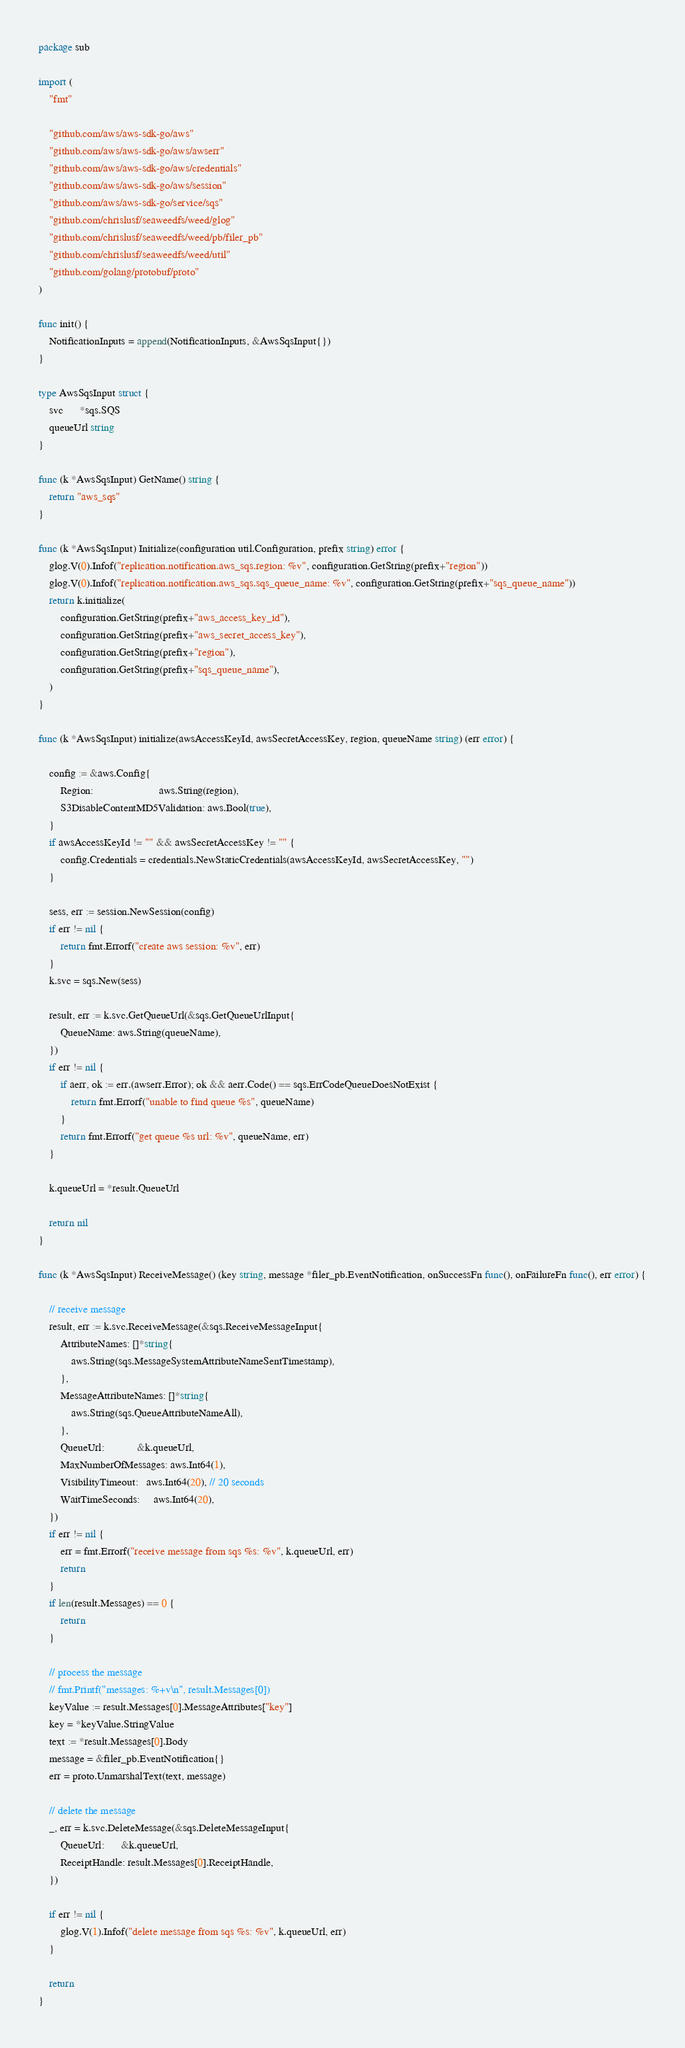<code> <loc_0><loc_0><loc_500><loc_500><_Go_>package sub

import (
	"fmt"

	"github.com/aws/aws-sdk-go/aws"
	"github.com/aws/aws-sdk-go/aws/awserr"
	"github.com/aws/aws-sdk-go/aws/credentials"
	"github.com/aws/aws-sdk-go/aws/session"
	"github.com/aws/aws-sdk-go/service/sqs"
	"github.com/chrislusf/seaweedfs/weed/glog"
	"github.com/chrislusf/seaweedfs/weed/pb/filer_pb"
	"github.com/chrislusf/seaweedfs/weed/util"
	"github.com/golang/protobuf/proto"
)

func init() {
	NotificationInputs = append(NotificationInputs, &AwsSqsInput{})
}

type AwsSqsInput struct {
	svc      *sqs.SQS
	queueUrl string
}

func (k *AwsSqsInput) GetName() string {
	return "aws_sqs"
}

func (k *AwsSqsInput) Initialize(configuration util.Configuration, prefix string) error {
	glog.V(0).Infof("replication.notification.aws_sqs.region: %v", configuration.GetString(prefix+"region"))
	glog.V(0).Infof("replication.notification.aws_sqs.sqs_queue_name: %v", configuration.GetString(prefix+"sqs_queue_name"))
	return k.initialize(
		configuration.GetString(prefix+"aws_access_key_id"),
		configuration.GetString(prefix+"aws_secret_access_key"),
		configuration.GetString(prefix+"region"),
		configuration.GetString(prefix+"sqs_queue_name"),
	)
}

func (k *AwsSqsInput) initialize(awsAccessKeyId, awsSecretAccessKey, region, queueName string) (err error) {

	config := &aws.Config{
		Region:                        aws.String(region),
		S3DisableContentMD5Validation: aws.Bool(true),
	}
	if awsAccessKeyId != "" && awsSecretAccessKey != "" {
		config.Credentials = credentials.NewStaticCredentials(awsAccessKeyId, awsSecretAccessKey, "")
	}

	sess, err := session.NewSession(config)
	if err != nil {
		return fmt.Errorf("create aws session: %v", err)
	}
	k.svc = sqs.New(sess)

	result, err := k.svc.GetQueueUrl(&sqs.GetQueueUrlInput{
		QueueName: aws.String(queueName),
	})
	if err != nil {
		if aerr, ok := err.(awserr.Error); ok && aerr.Code() == sqs.ErrCodeQueueDoesNotExist {
			return fmt.Errorf("unable to find queue %s", queueName)
		}
		return fmt.Errorf("get queue %s url: %v", queueName, err)
	}

	k.queueUrl = *result.QueueUrl

	return nil
}

func (k *AwsSqsInput) ReceiveMessage() (key string, message *filer_pb.EventNotification, onSuccessFn func(), onFailureFn func(), err error) {

	// receive message
	result, err := k.svc.ReceiveMessage(&sqs.ReceiveMessageInput{
		AttributeNames: []*string{
			aws.String(sqs.MessageSystemAttributeNameSentTimestamp),
		},
		MessageAttributeNames: []*string{
			aws.String(sqs.QueueAttributeNameAll),
		},
		QueueUrl:            &k.queueUrl,
		MaxNumberOfMessages: aws.Int64(1),
		VisibilityTimeout:   aws.Int64(20), // 20 seconds
		WaitTimeSeconds:     aws.Int64(20),
	})
	if err != nil {
		err = fmt.Errorf("receive message from sqs %s: %v", k.queueUrl, err)
		return
	}
	if len(result.Messages) == 0 {
		return
	}

	// process the message
	// fmt.Printf("messages: %+v\n", result.Messages[0])
	keyValue := result.Messages[0].MessageAttributes["key"]
	key = *keyValue.StringValue
	text := *result.Messages[0].Body
	message = &filer_pb.EventNotification{}
	err = proto.UnmarshalText(text, message)

	// delete the message
	_, err = k.svc.DeleteMessage(&sqs.DeleteMessageInput{
		QueueUrl:      &k.queueUrl,
		ReceiptHandle: result.Messages[0].ReceiptHandle,
	})

	if err != nil {
		glog.V(1).Infof("delete message from sqs %s: %v", k.queueUrl, err)
	}

	return
}
</code> 